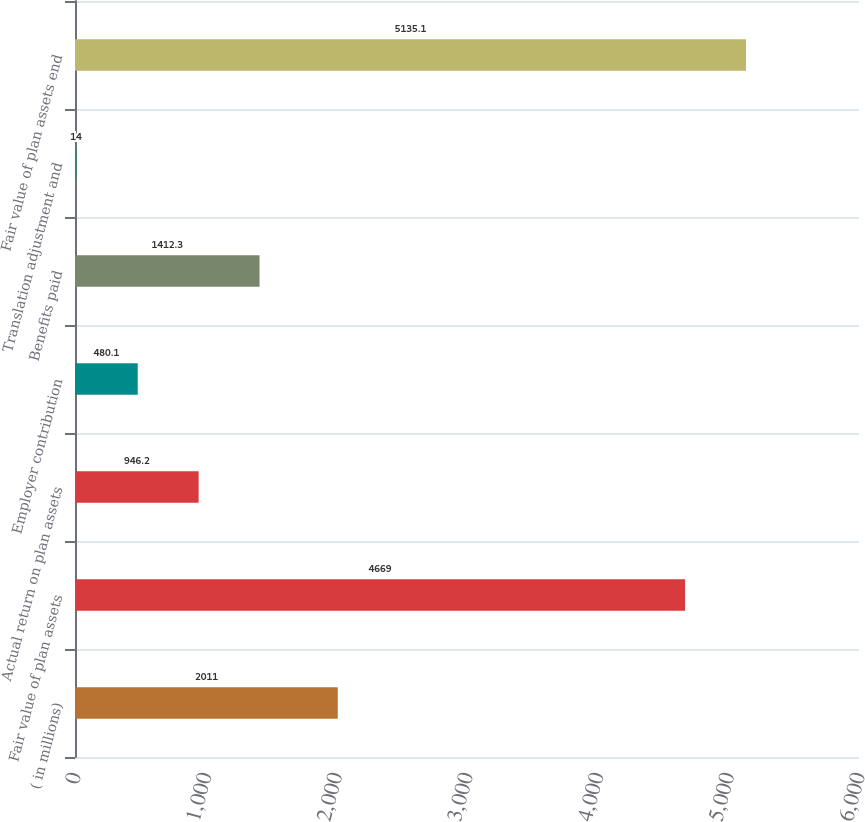Convert chart to OTSL. <chart><loc_0><loc_0><loc_500><loc_500><bar_chart><fcel>( in millions)<fcel>Fair value of plan assets<fcel>Actual return on plan assets<fcel>Employer contribution<fcel>Benefits paid<fcel>Translation adjustment and<fcel>Fair value of plan assets end<nl><fcel>2011<fcel>4669<fcel>946.2<fcel>480.1<fcel>1412.3<fcel>14<fcel>5135.1<nl></chart> 